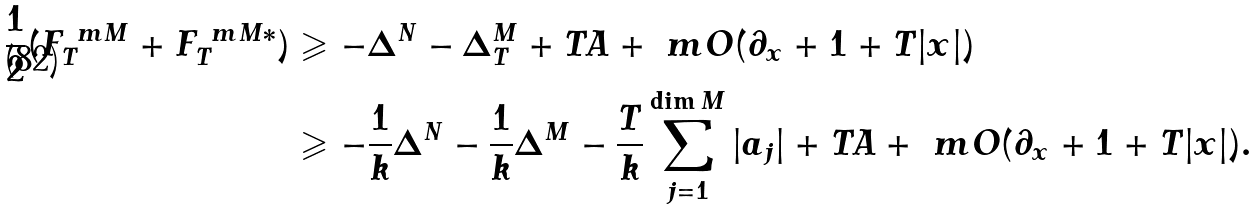Convert formula to latex. <formula><loc_0><loc_0><loc_500><loc_500>\frac { 1 } { 2 } ( F ^ { \ m M } _ { T } + F ^ { \ m M * } _ { T } ) & \geqslant - \Delta ^ { N } - \Delta _ { T } ^ { M } + T A + \ m O ( \partial _ { x } + 1 + T | x | ) \\ & \geqslant - \frac { 1 } { k } \Delta ^ { N } - \frac { 1 } { k } \Delta ^ { M } - \frac { T } { k } \sum _ { j = 1 } ^ { \dim M } | a _ { j } | + T A + \ m O ( \partial _ { x } + 1 + T | x | ) .</formula> 